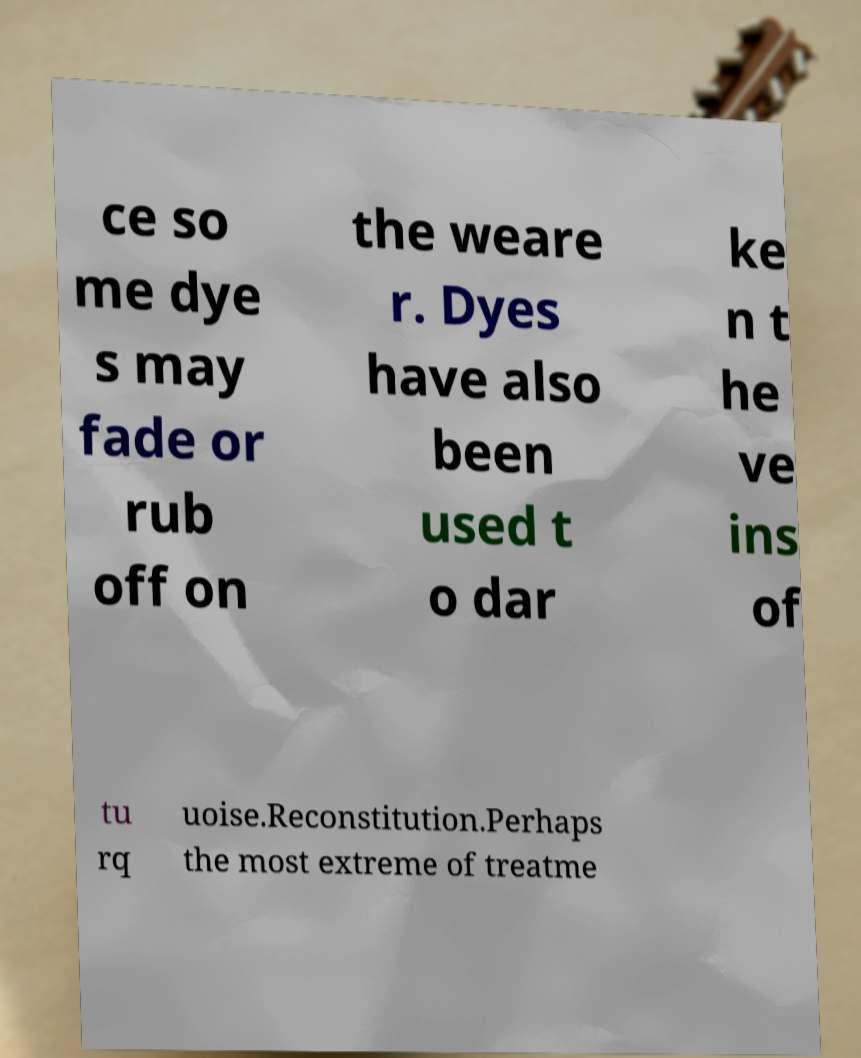Please identify and transcribe the text found in this image. ce so me dye s may fade or rub off on the weare r. Dyes have also been used t o dar ke n t he ve ins of tu rq uoise.Reconstitution.Perhaps the most extreme of treatme 